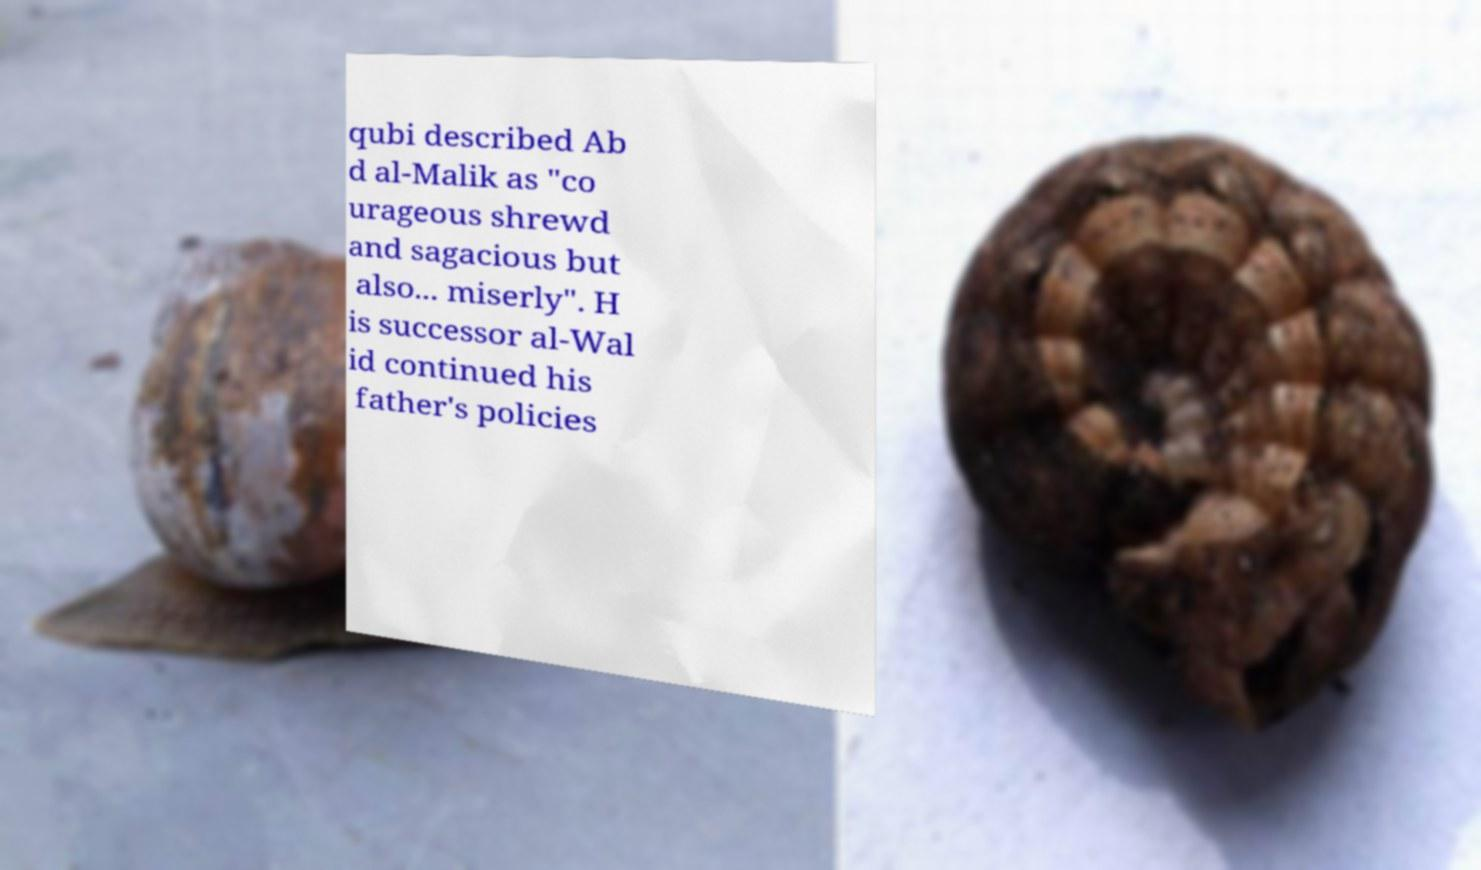What messages or text are displayed in this image? I need them in a readable, typed format. qubi described Ab d al-Malik as "co urageous shrewd and sagacious but also... miserly". H is successor al-Wal id continued his father's policies 